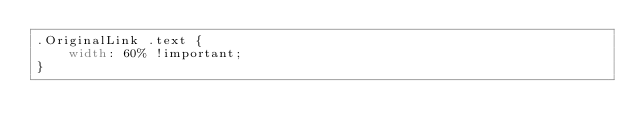Convert code to text. <code><loc_0><loc_0><loc_500><loc_500><_CSS_>.OriginalLink .text {
    width: 60% !important;
}</code> 